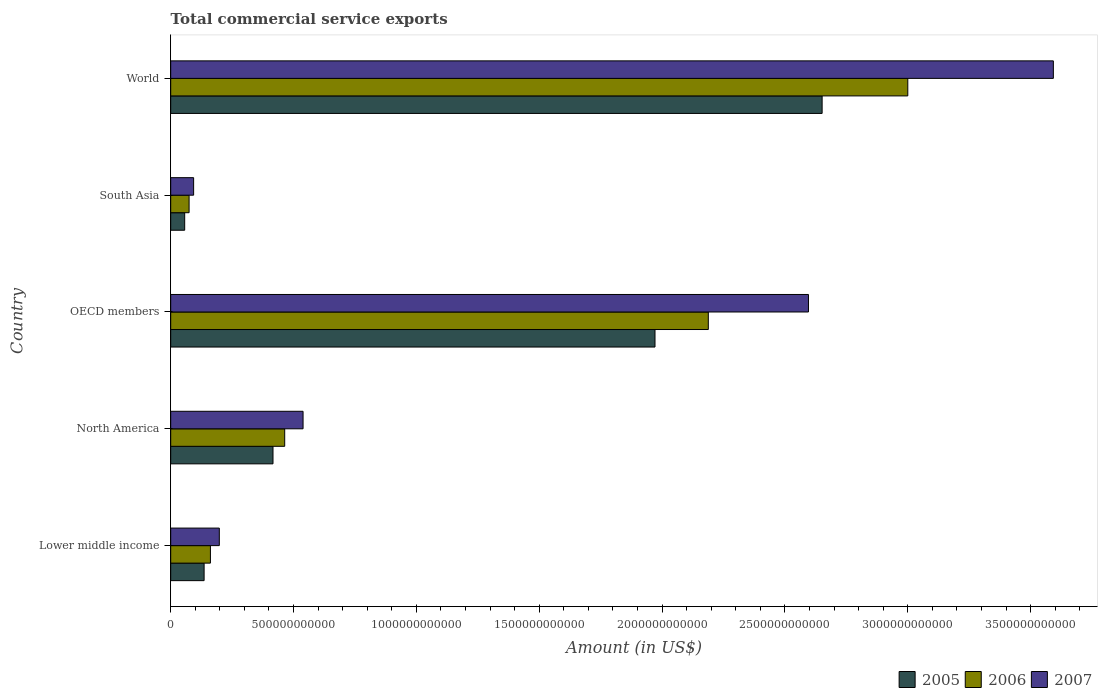How many different coloured bars are there?
Give a very brief answer. 3. How many groups of bars are there?
Ensure brevity in your answer.  5. What is the label of the 3rd group of bars from the top?
Give a very brief answer. OECD members. In how many cases, is the number of bars for a given country not equal to the number of legend labels?
Offer a terse response. 0. What is the total commercial service exports in 2007 in Lower middle income?
Your answer should be very brief. 1.98e+11. Across all countries, what is the maximum total commercial service exports in 2006?
Your response must be concise. 3.00e+12. Across all countries, what is the minimum total commercial service exports in 2007?
Provide a short and direct response. 9.33e+1. In which country was the total commercial service exports in 2006 minimum?
Make the answer very short. South Asia. What is the total total commercial service exports in 2006 in the graph?
Keep it short and to the point. 5.89e+12. What is the difference between the total commercial service exports in 2005 in South Asia and that in World?
Provide a short and direct response. -2.59e+12. What is the difference between the total commercial service exports in 2006 in Lower middle income and the total commercial service exports in 2005 in South Asia?
Provide a short and direct response. 1.05e+11. What is the average total commercial service exports in 2005 per country?
Provide a short and direct response. 1.05e+12. What is the difference between the total commercial service exports in 2005 and total commercial service exports in 2006 in World?
Your answer should be compact. -3.49e+11. What is the ratio of the total commercial service exports in 2007 in North America to that in South Asia?
Your answer should be compact. 5.77. Is the total commercial service exports in 2006 in Lower middle income less than that in OECD members?
Your answer should be compact. Yes. Is the difference between the total commercial service exports in 2005 in Lower middle income and South Asia greater than the difference between the total commercial service exports in 2006 in Lower middle income and South Asia?
Make the answer very short. No. What is the difference between the highest and the second highest total commercial service exports in 2006?
Offer a very short reply. 8.12e+11. What is the difference between the highest and the lowest total commercial service exports in 2005?
Offer a very short reply. 2.59e+12. Is the sum of the total commercial service exports in 2007 in OECD members and South Asia greater than the maximum total commercial service exports in 2006 across all countries?
Keep it short and to the point. No. What does the 3rd bar from the bottom in South Asia represents?
Offer a terse response. 2007. Is it the case that in every country, the sum of the total commercial service exports in 2005 and total commercial service exports in 2007 is greater than the total commercial service exports in 2006?
Your answer should be compact. Yes. Are all the bars in the graph horizontal?
Your answer should be compact. Yes. How many countries are there in the graph?
Offer a very short reply. 5. What is the difference between two consecutive major ticks on the X-axis?
Offer a terse response. 5.00e+11. Does the graph contain grids?
Provide a succinct answer. No. Where does the legend appear in the graph?
Your answer should be very brief. Bottom right. What is the title of the graph?
Your answer should be compact. Total commercial service exports. What is the Amount (in US$) in 2005 in Lower middle income?
Provide a short and direct response. 1.36e+11. What is the Amount (in US$) of 2006 in Lower middle income?
Your response must be concise. 1.62e+11. What is the Amount (in US$) in 2007 in Lower middle income?
Provide a succinct answer. 1.98e+11. What is the Amount (in US$) in 2005 in North America?
Your response must be concise. 4.16e+11. What is the Amount (in US$) of 2006 in North America?
Keep it short and to the point. 4.64e+11. What is the Amount (in US$) of 2007 in North America?
Your response must be concise. 5.39e+11. What is the Amount (in US$) in 2005 in OECD members?
Ensure brevity in your answer.  1.97e+12. What is the Amount (in US$) of 2006 in OECD members?
Offer a terse response. 2.19e+12. What is the Amount (in US$) in 2007 in OECD members?
Make the answer very short. 2.60e+12. What is the Amount (in US$) in 2005 in South Asia?
Provide a short and direct response. 5.69e+1. What is the Amount (in US$) in 2006 in South Asia?
Provide a short and direct response. 7.48e+1. What is the Amount (in US$) in 2007 in South Asia?
Ensure brevity in your answer.  9.33e+1. What is the Amount (in US$) in 2005 in World?
Make the answer very short. 2.65e+12. What is the Amount (in US$) in 2006 in World?
Make the answer very short. 3.00e+12. What is the Amount (in US$) in 2007 in World?
Give a very brief answer. 3.59e+12. Across all countries, what is the maximum Amount (in US$) of 2005?
Your response must be concise. 2.65e+12. Across all countries, what is the maximum Amount (in US$) of 2006?
Offer a terse response. 3.00e+12. Across all countries, what is the maximum Amount (in US$) of 2007?
Keep it short and to the point. 3.59e+12. Across all countries, what is the minimum Amount (in US$) of 2005?
Provide a short and direct response. 5.69e+1. Across all countries, what is the minimum Amount (in US$) in 2006?
Your answer should be very brief. 7.48e+1. Across all countries, what is the minimum Amount (in US$) in 2007?
Offer a terse response. 9.33e+1. What is the total Amount (in US$) of 2005 in the graph?
Your response must be concise. 5.23e+12. What is the total Amount (in US$) in 2006 in the graph?
Offer a terse response. 5.89e+12. What is the total Amount (in US$) of 2007 in the graph?
Offer a terse response. 7.02e+12. What is the difference between the Amount (in US$) of 2005 in Lower middle income and that in North America?
Make the answer very short. -2.80e+11. What is the difference between the Amount (in US$) of 2006 in Lower middle income and that in North America?
Make the answer very short. -3.02e+11. What is the difference between the Amount (in US$) of 2007 in Lower middle income and that in North America?
Your answer should be compact. -3.41e+11. What is the difference between the Amount (in US$) of 2005 in Lower middle income and that in OECD members?
Offer a very short reply. -1.84e+12. What is the difference between the Amount (in US$) of 2006 in Lower middle income and that in OECD members?
Offer a terse response. -2.03e+12. What is the difference between the Amount (in US$) in 2007 in Lower middle income and that in OECD members?
Your answer should be compact. -2.40e+12. What is the difference between the Amount (in US$) in 2005 in Lower middle income and that in South Asia?
Your response must be concise. 7.91e+1. What is the difference between the Amount (in US$) of 2006 in Lower middle income and that in South Asia?
Offer a terse response. 8.68e+1. What is the difference between the Amount (in US$) of 2007 in Lower middle income and that in South Asia?
Ensure brevity in your answer.  1.05e+11. What is the difference between the Amount (in US$) in 2005 in Lower middle income and that in World?
Offer a very short reply. -2.52e+12. What is the difference between the Amount (in US$) of 2006 in Lower middle income and that in World?
Offer a terse response. -2.84e+12. What is the difference between the Amount (in US$) in 2007 in Lower middle income and that in World?
Your answer should be compact. -3.39e+12. What is the difference between the Amount (in US$) in 2005 in North America and that in OECD members?
Keep it short and to the point. -1.55e+12. What is the difference between the Amount (in US$) in 2006 in North America and that in OECD members?
Give a very brief answer. -1.72e+12. What is the difference between the Amount (in US$) of 2007 in North America and that in OECD members?
Your response must be concise. -2.06e+12. What is the difference between the Amount (in US$) of 2005 in North America and that in South Asia?
Make the answer very short. 3.59e+11. What is the difference between the Amount (in US$) of 2006 in North America and that in South Asia?
Keep it short and to the point. 3.89e+11. What is the difference between the Amount (in US$) of 2007 in North America and that in South Asia?
Provide a short and direct response. 4.45e+11. What is the difference between the Amount (in US$) of 2005 in North America and that in World?
Give a very brief answer. -2.23e+12. What is the difference between the Amount (in US$) of 2006 in North America and that in World?
Your response must be concise. -2.54e+12. What is the difference between the Amount (in US$) in 2007 in North America and that in World?
Provide a succinct answer. -3.05e+12. What is the difference between the Amount (in US$) of 2005 in OECD members and that in South Asia?
Provide a succinct answer. 1.91e+12. What is the difference between the Amount (in US$) of 2006 in OECD members and that in South Asia?
Your answer should be very brief. 2.11e+12. What is the difference between the Amount (in US$) in 2007 in OECD members and that in South Asia?
Your answer should be compact. 2.50e+12. What is the difference between the Amount (in US$) in 2005 in OECD members and that in World?
Your answer should be very brief. -6.80e+11. What is the difference between the Amount (in US$) of 2006 in OECD members and that in World?
Offer a terse response. -8.12e+11. What is the difference between the Amount (in US$) of 2007 in OECD members and that in World?
Ensure brevity in your answer.  -9.97e+11. What is the difference between the Amount (in US$) in 2005 in South Asia and that in World?
Provide a short and direct response. -2.59e+12. What is the difference between the Amount (in US$) in 2006 in South Asia and that in World?
Your answer should be very brief. -2.93e+12. What is the difference between the Amount (in US$) in 2007 in South Asia and that in World?
Your answer should be very brief. -3.50e+12. What is the difference between the Amount (in US$) of 2005 in Lower middle income and the Amount (in US$) of 2006 in North America?
Make the answer very short. -3.28e+11. What is the difference between the Amount (in US$) in 2005 in Lower middle income and the Amount (in US$) in 2007 in North America?
Make the answer very short. -4.03e+11. What is the difference between the Amount (in US$) in 2006 in Lower middle income and the Amount (in US$) in 2007 in North America?
Your response must be concise. -3.77e+11. What is the difference between the Amount (in US$) in 2005 in Lower middle income and the Amount (in US$) in 2006 in OECD members?
Make the answer very short. -2.05e+12. What is the difference between the Amount (in US$) in 2005 in Lower middle income and the Amount (in US$) in 2007 in OECD members?
Your answer should be very brief. -2.46e+12. What is the difference between the Amount (in US$) of 2006 in Lower middle income and the Amount (in US$) of 2007 in OECD members?
Your answer should be compact. -2.43e+12. What is the difference between the Amount (in US$) of 2005 in Lower middle income and the Amount (in US$) of 2006 in South Asia?
Your response must be concise. 6.12e+1. What is the difference between the Amount (in US$) of 2005 in Lower middle income and the Amount (in US$) of 2007 in South Asia?
Offer a very short reply. 4.27e+1. What is the difference between the Amount (in US$) in 2006 in Lower middle income and the Amount (in US$) in 2007 in South Asia?
Give a very brief answer. 6.84e+1. What is the difference between the Amount (in US$) in 2005 in Lower middle income and the Amount (in US$) in 2006 in World?
Ensure brevity in your answer.  -2.86e+12. What is the difference between the Amount (in US$) of 2005 in Lower middle income and the Amount (in US$) of 2007 in World?
Provide a short and direct response. -3.46e+12. What is the difference between the Amount (in US$) of 2006 in Lower middle income and the Amount (in US$) of 2007 in World?
Offer a terse response. -3.43e+12. What is the difference between the Amount (in US$) in 2005 in North America and the Amount (in US$) in 2006 in OECD members?
Provide a short and direct response. -1.77e+12. What is the difference between the Amount (in US$) of 2005 in North America and the Amount (in US$) of 2007 in OECD members?
Keep it short and to the point. -2.18e+12. What is the difference between the Amount (in US$) of 2006 in North America and the Amount (in US$) of 2007 in OECD members?
Give a very brief answer. -2.13e+12. What is the difference between the Amount (in US$) in 2005 in North America and the Amount (in US$) in 2006 in South Asia?
Ensure brevity in your answer.  3.42e+11. What is the difference between the Amount (in US$) in 2005 in North America and the Amount (in US$) in 2007 in South Asia?
Provide a succinct answer. 3.23e+11. What is the difference between the Amount (in US$) of 2006 in North America and the Amount (in US$) of 2007 in South Asia?
Your answer should be compact. 3.71e+11. What is the difference between the Amount (in US$) of 2005 in North America and the Amount (in US$) of 2006 in World?
Give a very brief answer. -2.58e+12. What is the difference between the Amount (in US$) in 2005 in North America and the Amount (in US$) in 2007 in World?
Your response must be concise. -3.18e+12. What is the difference between the Amount (in US$) of 2006 in North America and the Amount (in US$) of 2007 in World?
Offer a terse response. -3.13e+12. What is the difference between the Amount (in US$) of 2005 in OECD members and the Amount (in US$) of 2006 in South Asia?
Ensure brevity in your answer.  1.90e+12. What is the difference between the Amount (in US$) in 2005 in OECD members and the Amount (in US$) in 2007 in South Asia?
Your answer should be very brief. 1.88e+12. What is the difference between the Amount (in US$) in 2006 in OECD members and the Amount (in US$) in 2007 in South Asia?
Offer a terse response. 2.09e+12. What is the difference between the Amount (in US$) of 2005 in OECD members and the Amount (in US$) of 2006 in World?
Give a very brief answer. -1.03e+12. What is the difference between the Amount (in US$) of 2005 in OECD members and the Amount (in US$) of 2007 in World?
Ensure brevity in your answer.  -1.62e+12. What is the difference between the Amount (in US$) of 2006 in OECD members and the Amount (in US$) of 2007 in World?
Make the answer very short. -1.40e+12. What is the difference between the Amount (in US$) of 2005 in South Asia and the Amount (in US$) of 2006 in World?
Make the answer very short. -2.94e+12. What is the difference between the Amount (in US$) of 2005 in South Asia and the Amount (in US$) of 2007 in World?
Make the answer very short. -3.54e+12. What is the difference between the Amount (in US$) in 2006 in South Asia and the Amount (in US$) in 2007 in World?
Provide a succinct answer. -3.52e+12. What is the average Amount (in US$) of 2005 per country?
Make the answer very short. 1.05e+12. What is the average Amount (in US$) of 2006 per country?
Provide a short and direct response. 1.18e+12. What is the average Amount (in US$) of 2007 per country?
Provide a succinct answer. 1.40e+12. What is the difference between the Amount (in US$) of 2005 and Amount (in US$) of 2006 in Lower middle income?
Your answer should be compact. -2.57e+1. What is the difference between the Amount (in US$) in 2005 and Amount (in US$) in 2007 in Lower middle income?
Make the answer very short. -6.19e+1. What is the difference between the Amount (in US$) of 2006 and Amount (in US$) of 2007 in Lower middle income?
Your response must be concise. -3.62e+1. What is the difference between the Amount (in US$) in 2005 and Amount (in US$) in 2006 in North America?
Offer a very short reply. -4.76e+1. What is the difference between the Amount (in US$) of 2005 and Amount (in US$) of 2007 in North America?
Give a very brief answer. -1.22e+11. What is the difference between the Amount (in US$) of 2006 and Amount (in US$) of 2007 in North America?
Your answer should be compact. -7.47e+1. What is the difference between the Amount (in US$) in 2005 and Amount (in US$) in 2006 in OECD members?
Your response must be concise. -2.17e+11. What is the difference between the Amount (in US$) of 2005 and Amount (in US$) of 2007 in OECD members?
Give a very brief answer. -6.25e+11. What is the difference between the Amount (in US$) of 2006 and Amount (in US$) of 2007 in OECD members?
Make the answer very short. -4.08e+11. What is the difference between the Amount (in US$) of 2005 and Amount (in US$) of 2006 in South Asia?
Your response must be concise. -1.79e+1. What is the difference between the Amount (in US$) in 2005 and Amount (in US$) in 2007 in South Asia?
Ensure brevity in your answer.  -3.64e+1. What is the difference between the Amount (in US$) of 2006 and Amount (in US$) of 2007 in South Asia?
Offer a terse response. -1.85e+1. What is the difference between the Amount (in US$) in 2005 and Amount (in US$) in 2006 in World?
Ensure brevity in your answer.  -3.49e+11. What is the difference between the Amount (in US$) in 2005 and Amount (in US$) in 2007 in World?
Your response must be concise. -9.41e+11. What is the difference between the Amount (in US$) in 2006 and Amount (in US$) in 2007 in World?
Make the answer very short. -5.92e+11. What is the ratio of the Amount (in US$) of 2005 in Lower middle income to that in North America?
Provide a short and direct response. 0.33. What is the ratio of the Amount (in US$) in 2006 in Lower middle income to that in North America?
Offer a terse response. 0.35. What is the ratio of the Amount (in US$) in 2007 in Lower middle income to that in North America?
Give a very brief answer. 0.37. What is the ratio of the Amount (in US$) of 2005 in Lower middle income to that in OECD members?
Your response must be concise. 0.07. What is the ratio of the Amount (in US$) of 2006 in Lower middle income to that in OECD members?
Make the answer very short. 0.07. What is the ratio of the Amount (in US$) of 2007 in Lower middle income to that in OECD members?
Offer a terse response. 0.08. What is the ratio of the Amount (in US$) in 2005 in Lower middle income to that in South Asia?
Offer a terse response. 2.39. What is the ratio of the Amount (in US$) of 2006 in Lower middle income to that in South Asia?
Provide a succinct answer. 2.16. What is the ratio of the Amount (in US$) in 2007 in Lower middle income to that in South Asia?
Your response must be concise. 2.12. What is the ratio of the Amount (in US$) in 2005 in Lower middle income to that in World?
Provide a succinct answer. 0.05. What is the ratio of the Amount (in US$) in 2006 in Lower middle income to that in World?
Your answer should be compact. 0.05. What is the ratio of the Amount (in US$) in 2007 in Lower middle income to that in World?
Ensure brevity in your answer.  0.06. What is the ratio of the Amount (in US$) of 2005 in North America to that in OECD members?
Your response must be concise. 0.21. What is the ratio of the Amount (in US$) of 2006 in North America to that in OECD members?
Provide a succinct answer. 0.21. What is the ratio of the Amount (in US$) in 2007 in North America to that in OECD members?
Provide a succinct answer. 0.21. What is the ratio of the Amount (in US$) of 2005 in North America to that in South Asia?
Ensure brevity in your answer.  7.32. What is the ratio of the Amount (in US$) in 2006 in North America to that in South Asia?
Make the answer very short. 6.2. What is the ratio of the Amount (in US$) of 2007 in North America to that in South Asia?
Your answer should be very brief. 5.77. What is the ratio of the Amount (in US$) of 2005 in North America to that in World?
Keep it short and to the point. 0.16. What is the ratio of the Amount (in US$) of 2006 in North America to that in World?
Keep it short and to the point. 0.15. What is the ratio of the Amount (in US$) in 2005 in OECD members to that in South Asia?
Make the answer very short. 34.63. What is the ratio of the Amount (in US$) of 2006 in OECD members to that in South Asia?
Your answer should be compact. 29.24. What is the ratio of the Amount (in US$) in 2007 in OECD members to that in South Asia?
Offer a very short reply. 27.82. What is the ratio of the Amount (in US$) in 2005 in OECD members to that in World?
Ensure brevity in your answer.  0.74. What is the ratio of the Amount (in US$) in 2006 in OECD members to that in World?
Your answer should be very brief. 0.73. What is the ratio of the Amount (in US$) in 2007 in OECD members to that in World?
Provide a succinct answer. 0.72. What is the ratio of the Amount (in US$) in 2005 in South Asia to that in World?
Offer a terse response. 0.02. What is the ratio of the Amount (in US$) in 2006 in South Asia to that in World?
Offer a terse response. 0.02. What is the ratio of the Amount (in US$) of 2007 in South Asia to that in World?
Offer a very short reply. 0.03. What is the difference between the highest and the second highest Amount (in US$) in 2005?
Give a very brief answer. 6.80e+11. What is the difference between the highest and the second highest Amount (in US$) in 2006?
Provide a short and direct response. 8.12e+11. What is the difference between the highest and the second highest Amount (in US$) in 2007?
Keep it short and to the point. 9.97e+11. What is the difference between the highest and the lowest Amount (in US$) of 2005?
Offer a terse response. 2.59e+12. What is the difference between the highest and the lowest Amount (in US$) in 2006?
Keep it short and to the point. 2.93e+12. What is the difference between the highest and the lowest Amount (in US$) of 2007?
Give a very brief answer. 3.50e+12. 